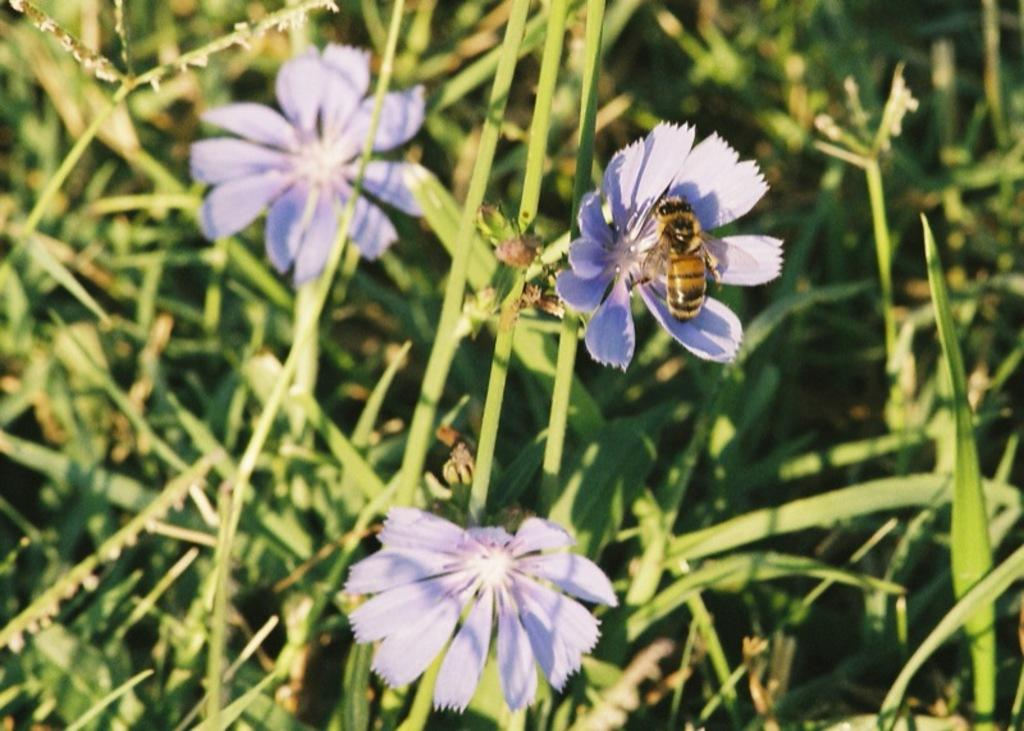What type of flowers can be seen in the image? There are purple color flowers in the image. Where are the flowers located? The flowers are on plants. Is there any other living organism present in the image? Yes, there is a black and brown color insect on one of the flowers. What type of rake is being used to collect the paper in the image? There is no rake or paper present in the image; it features purple flowers and an insect. What kind of steel structure can be seen in the background of the image? There is no steel structure visible in the image; it focuses on the flowers and insect. 